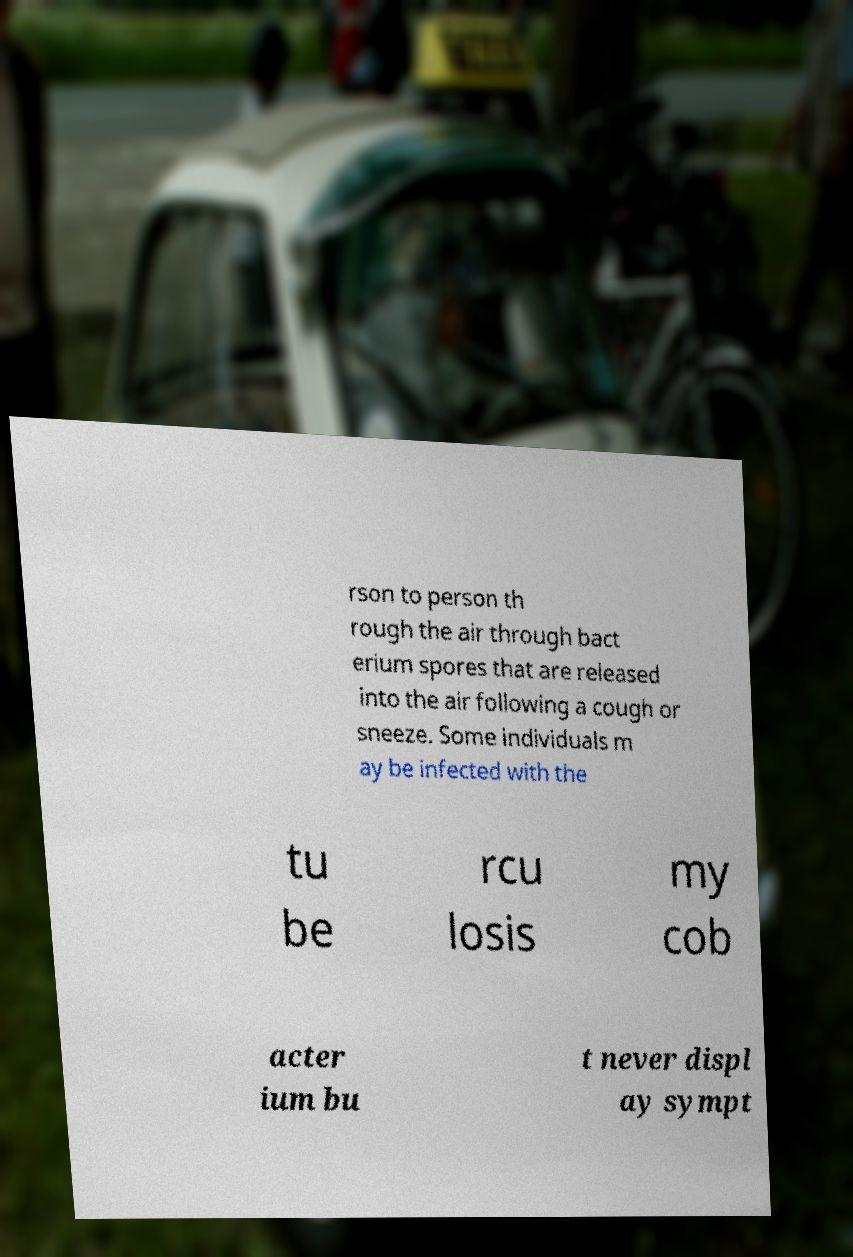Could you extract and type out the text from this image? rson to person th rough the air through bact erium spores that are released into the air following a cough or sneeze. Some individuals m ay be infected with the tu be rcu losis my cob acter ium bu t never displ ay sympt 